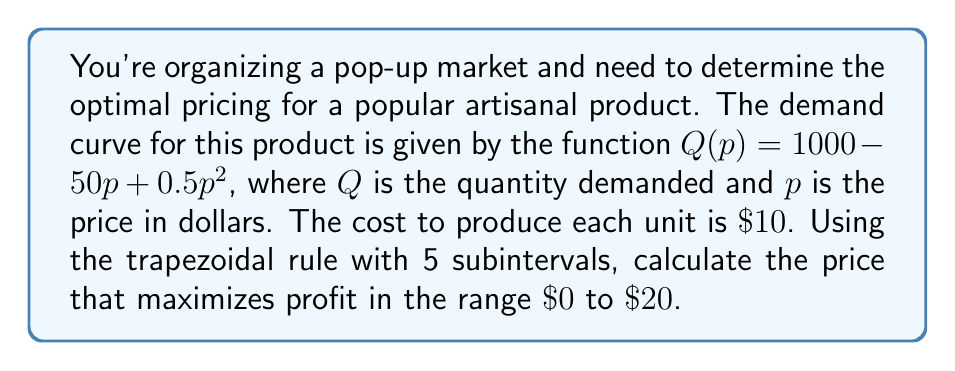Can you answer this question? 1) The profit function is given by $\Pi(p) = pQ(p) - 10Q(p)$, where $10$ is the cost per unit.

2) To find the maximum profit, we need to integrate the profit function and find its maximum value. The integral of the profit function is:

   $$\int_0^p \Pi(x) dx = \int_0^p (x-10)(1000 - 50x + 0.5x^2) dx$$

3) We'll use the trapezoidal rule with 5 subintervals to approximate this integral. The formula is:

   $$\int_a^b f(x) dx \approx \frac{h}{2}[f(x_0) + 2f(x_1) + 2f(x_2) + 2f(x_3) + 2f(x_4) + f(x_5)]$$

   where $h = \frac{b-a}{n}$, $n$ is the number of subintervals, and $x_i = a + ih$.

4) In our case, $a=0$, $b=20$, $n=5$, so $h = 4$. We need to evaluate $\Pi(p)$ at $p = 0, 4, 8, 12, 16, 20$.

5) Calculate $\Pi(p)$ for each price:
   $\Pi(0) = 0$
   $\Pi(4) = -6(1000 - 200 + 8) = -4848$
   $\Pi(8) = -2(1000 - 400 + 32) = -1264$
   $\Pi(12) = 2(1000 - 600 + 72) = 944$
   $\Pi(16) = 6(1000 - 800 + 128) = 1968$
   $\Pi(20) = 10(1000 - 1000 + 200) = 2000$

6) Apply the trapezoidal rule:
   $$\int_0^{20} \Pi(p) dp \approx \frac{4}{2}[0 + 2(-4848) + 2(-1264) + 2(944) + 2(1968) + 2000]$$
   $$= 2[-4848 - 2528 + 1888 + 3936 + 2000] = 896$$

7) The maximum of this approximation occurs at $p = 20$, with a profit of $2000.

Therefore, based on this numerical approximation, the optimal price is $\$20$.
Answer: $\$20$ 